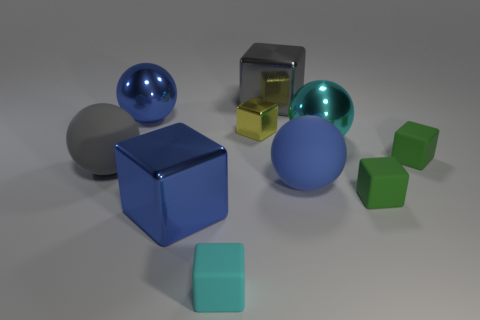What number of metallic objects are either small green blocks or large cubes?
Ensure brevity in your answer.  2. Do the big object that is in front of the large blue matte ball and the tiny metallic object have the same color?
Your answer should be compact. No. The large blue object that is on the right side of the cyan block in front of the yellow shiny object is what shape?
Provide a short and direct response. Sphere. How many things are balls that are on the left side of the blue matte thing or large objects behind the tiny shiny block?
Make the answer very short. 3. What is the shape of the blue thing that is made of the same material as the cyan cube?
Offer a terse response. Sphere. Are there any other things of the same color as the tiny metal cube?
Provide a succinct answer. No. There is a tiny cyan thing that is the same shape as the yellow object; what material is it?
Give a very brief answer. Rubber. How many other things are the same size as the cyan matte block?
Your answer should be compact. 3. What material is the tiny yellow block?
Ensure brevity in your answer.  Metal. Are there more gray blocks that are to the left of the small metal object than tiny rubber cubes?
Provide a succinct answer. No. 